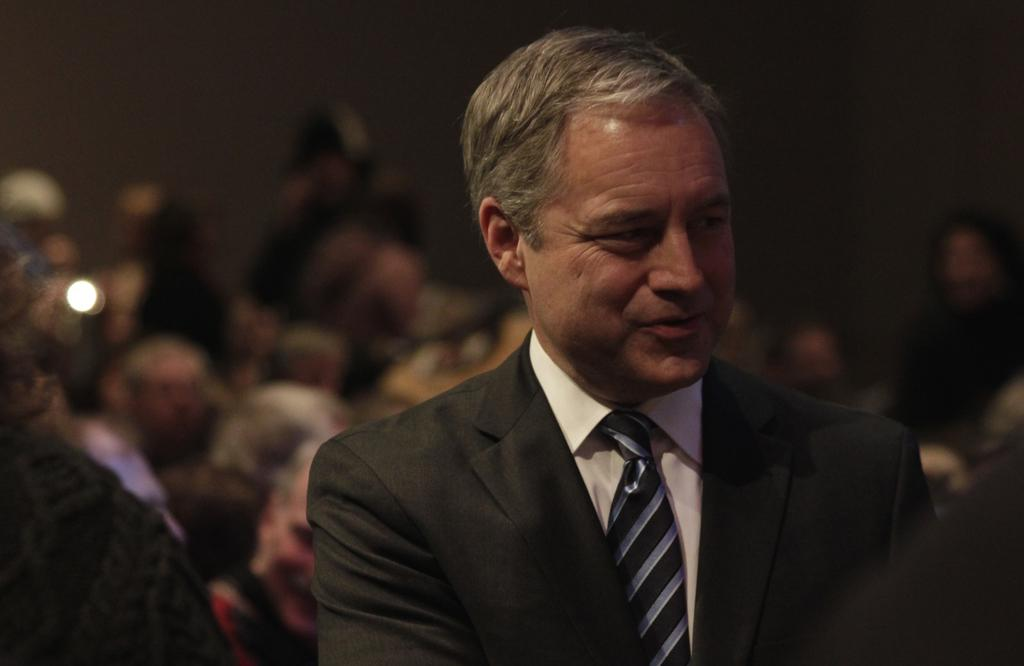Who is present in the image? There is a man in the image. What is the man wearing around his neck? The man is wearing a tie. What type of clothing is the man wearing on his upper body? The man is wearing a shirt. What color is the suit the man is wearing? The man is wearing a black color suit. Can you describe the background of the image? The background of the image is blurred. How many planes are participating in the competition in the image? There are no planes or competitions present in the image; it features a man wearing a suit and tie. 